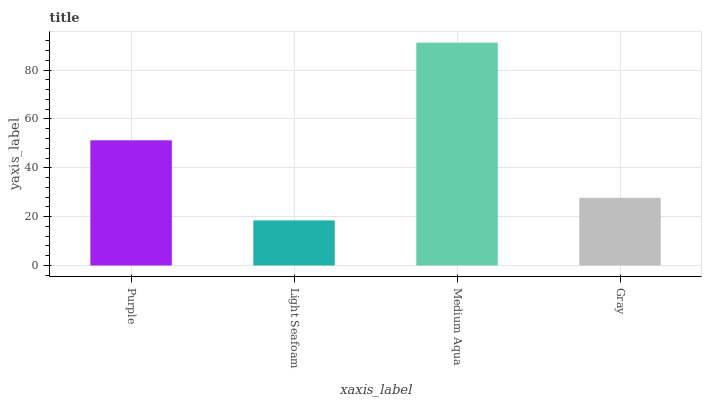Is Medium Aqua the minimum?
Answer yes or no. No. Is Light Seafoam the maximum?
Answer yes or no. No. Is Medium Aqua greater than Light Seafoam?
Answer yes or no. Yes. Is Light Seafoam less than Medium Aqua?
Answer yes or no. Yes. Is Light Seafoam greater than Medium Aqua?
Answer yes or no. No. Is Medium Aqua less than Light Seafoam?
Answer yes or no. No. Is Purple the high median?
Answer yes or no. Yes. Is Gray the low median?
Answer yes or no. Yes. Is Light Seafoam the high median?
Answer yes or no. No. Is Medium Aqua the low median?
Answer yes or no. No. 